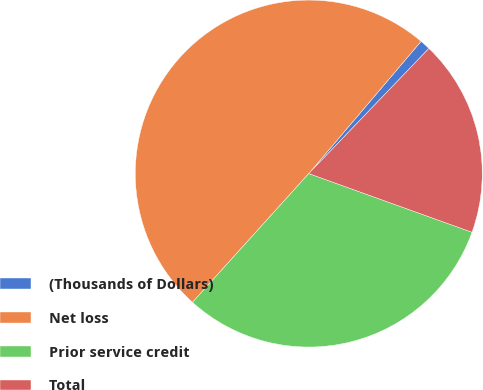Convert chart. <chart><loc_0><loc_0><loc_500><loc_500><pie_chart><fcel>(Thousands of Dollars)<fcel>Net loss<fcel>Prior service credit<fcel>Total<nl><fcel>0.97%<fcel>49.52%<fcel>31.2%<fcel>18.32%<nl></chart> 